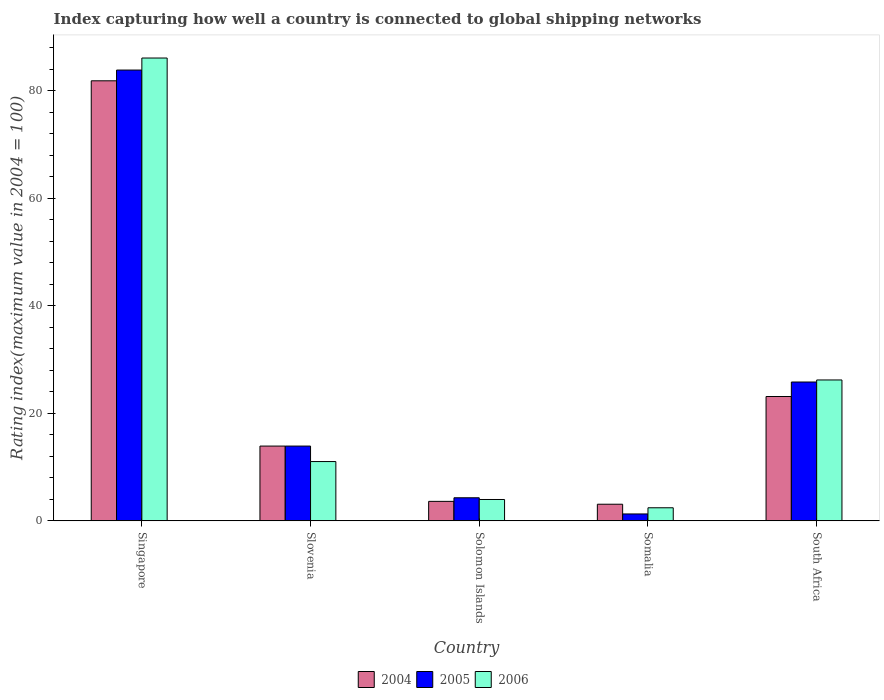How many different coloured bars are there?
Keep it short and to the point. 3. How many groups of bars are there?
Give a very brief answer. 5. Are the number of bars on each tick of the X-axis equal?
Your answer should be very brief. Yes. How many bars are there on the 5th tick from the left?
Make the answer very short. 3. What is the label of the 4th group of bars from the left?
Give a very brief answer. Somalia. What is the rating index in 2005 in South Africa?
Your response must be concise. 25.83. Across all countries, what is the maximum rating index in 2004?
Your answer should be compact. 81.87. Across all countries, what is the minimum rating index in 2004?
Your response must be concise. 3.09. In which country was the rating index in 2004 maximum?
Provide a short and direct response. Singapore. In which country was the rating index in 2004 minimum?
Ensure brevity in your answer.  Somalia. What is the total rating index in 2006 in the graph?
Your response must be concise. 129.75. What is the difference between the rating index in 2005 in Singapore and that in Solomon Islands?
Make the answer very short. 79.58. What is the difference between the rating index in 2006 in Slovenia and the rating index in 2005 in Singapore?
Provide a short and direct response. -72.84. What is the average rating index in 2005 per country?
Provide a succinct answer. 25.84. What is the difference between the rating index of/in 2006 and rating index of/in 2005 in Somalia?
Give a very brief answer. 1.15. What is the ratio of the rating index in 2005 in Slovenia to that in Solomon Islands?
Offer a very short reply. 3.24. Is the rating index in 2006 in Solomon Islands less than that in Somalia?
Your answer should be compact. No. Is the difference between the rating index in 2006 in Singapore and Slovenia greater than the difference between the rating index in 2005 in Singapore and Slovenia?
Your response must be concise. Yes. What is the difference between the highest and the second highest rating index in 2005?
Ensure brevity in your answer.  -58.04. What is the difference between the highest and the lowest rating index in 2005?
Provide a short and direct response. 82.59. Is the sum of the rating index in 2004 in Singapore and Solomon Islands greater than the maximum rating index in 2005 across all countries?
Offer a very short reply. Yes. Is it the case that in every country, the sum of the rating index in 2006 and rating index in 2005 is greater than the rating index in 2004?
Provide a short and direct response. Yes. Are all the bars in the graph horizontal?
Provide a succinct answer. No. Are the values on the major ticks of Y-axis written in scientific E-notation?
Give a very brief answer. No. Does the graph contain any zero values?
Your response must be concise. No. How many legend labels are there?
Your response must be concise. 3. How are the legend labels stacked?
Offer a terse response. Horizontal. What is the title of the graph?
Ensure brevity in your answer.  Index capturing how well a country is connected to global shipping networks. What is the label or title of the Y-axis?
Offer a very short reply. Rating index(maximum value in 2004 = 100). What is the Rating index(maximum value in 2004 = 100) in 2004 in Singapore?
Keep it short and to the point. 81.87. What is the Rating index(maximum value in 2004 = 100) in 2005 in Singapore?
Ensure brevity in your answer.  83.87. What is the Rating index(maximum value in 2004 = 100) of 2006 in Singapore?
Provide a succinct answer. 86.11. What is the Rating index(maximum value in 2004 = 100) of 2004 in Slovenia?
Provide a short and direct response. 13.91. What is the Rating index(maximum value in 2004 = 100) of 2005 in Slovenia?
Ensure brevity in your answer.  13.91. What is the Rating index(maximum value in 2004 = 100) of 2006 in Slovenia?
Make the answer very short. 11.03. What is the Rating index(maximum value in 2004 = 100) of 2004 in Solomon Islands?
Your answer should be compact. 3.62. What is the Rating index(maximum value in 2004 = 100) in 2005 in Solomon Islands?
Make the answer very short. 4.29. What is the Rating index(maximum value in 2004 = 100) of 2006 in Solomon Islands?
Make the answer very short. 3.97. What is the Rating index(maximum value in 2004 = 100) in 2004 in Somalia?
Provide a short and direct response. 3.09. What is the Rating index(maximum value in 2004 = 100) of 2005 in Somalia?
Give a very brief answer. 1.28. What is the Rating index(maximum value in 2004 = 100) in 2006 in Somalia?
Keep it short and to the point. 2.43. What is the Rating index(maximum value in 2004 = 100) of 2004 in South Africa?
Offer a terse response. 23.13. What is the Rating index(maximum value in 2004 = 100) of 2005 in South Africa?
Keep it short and to the point. 25.83. What is the Rating index(maximum value in 2004 = 100) in 2006 in South Africa?
Give a very brief answer. 26.21. Across all countries, what is the maximum Rating index(maximum value in 2004 = 100) in 2004?
Provide a succinct answer. 81.87. Across all countries, what is the maximum Rating index(maximum value in 2004 = 100) of 2005?
Your response must be concise. 83.87. Across all countries, what is the maximum Rating index(maximum value in 2004 = 100) in 2006?
Provide a succinct answer. 86.11. Across all countries, what is the minimum Rating index(maximum value in 2004 = 100) in 2004?
Your answer should be very brief. 3.09. Across all countries, what is the minimum Rating index(maximum value in 2004 = 100) in 2005?
Your response must be concise. 1.28. Across all countries, what is the minimum Rating index(maximum value in 2004 = 100) of 2006?
Keep it short and to the point. 2.43. What is the total Rating index(maximum value in 2004 = 100) in 2004 in the graph?
Your answer should be very brief. 125.62. What is the total Rating index(maximum value in 2004 = 100) in 2005 in the graph?
Offer a very short reply. 129.18. What is the total Rating index(maximum value in 2004 = 100) of 2006 in the graph?
Give a very brief answer. 129.75. What is the difference between the Rating index(maximum value in 2004 = 100) in 2004 in Singapore and that in Slovenia?
Make the answer very short. 67.96. What is the difference between the Rating index(maximum value in 2004 = 100) of 2005 in Singapore and that in Slovenia?
Offer a very short reply. 69.96. What is the difference between the Rating index(maximum value in 2004 = 100) of 2006 in Singapore and that in Slovenia?
Offer a terse response. 75.08. What is the difference between the Rating index(maximum value in 2004 = 100) of 2004 in Singapore and that in Solomon Islands?
Your answer should be compact. 78.25. What is the difference between the Rating index(maximum value in 2004 = 100) of 2005 in Singapore and that in Solomon Islands?
Provide a short and direct response. 79.58. What is the difference between the Rating index(maximum value in 2004 = 100) of 2006 in Singapore and that in Solomon Islands?
Make the answer very short. 82.14. What is the difference between the Rating index(maximum value in 2004 = 100) of 2004 in Singapore and that in Somalia?
Offer a very short reply. 78.78. What is the difference between the Rating index(maximum value in 2004 = 100) in 2005 in Singapore and that in Somalia?
Provide a short and direct response. 82.59. What is the difference between the Rating index(maximum value in 2004 = 100) in 2006 in Singapore and that in Somalia?
Offer a very short reply. 83.68. What is the difference between the Rating index(maximum value in 2004 = 100) of 2004 in Singapore and that in South Africa?
Give a very brief answer. 58.74. What is the difference between the Rating index(maximum value in 2004 = 100) of 2005 in Singapore and that in South Africa?
Give a very brief answer. 58.04. What is the difference between the Rating index(maximum value in 2004 = 100) in 2006 in Singapore and that in South Africa?
Provide a short and direct response. 59.9. What is the difference between the Rating index(maximum value in 2004 = 100) in 2004 in Slovenia and that in Solomon Islands?
Your answer should be compact. 10.29. What is the difference between the Rating index(maximum value in 2004 = 100) of 2005 in Slovenia and that in Solomon Islands?
Your answer should be compact. 9.62. What is the difference between the Rating index(maximum value in 2004 = 100) of 2006 in Slovenia and that in Solomon Islands?
Your response must be concise. 7.06. What is the difference between the Rating index(maximum value in 2004 = 100) in 2004 in Slovenia and that in Somalia?
Your answer should be very brief. 10.82. What is the difference between the Rating index(maximum value in 2004 = 100) in 2005 in Slovenia and that in Somalia?
Offer a very short reply. 12.63. What is the difference between the Rating index(maximum value in 2004 = 100) of 2006 in Slovenia and that in Somalia?
Your response must be concise. 8.6. What is the difference between the Rating index(maximum value in 2004 = 100) of 2004 in Slovenia and that in South Africa?
Provide a succinct answer. -9.22. What is the difference between the Rating index(maximum value in 2004 = 100) of 2005 in Slovenia and that in South Africa?
Keep it short and to the point. -11.92. What is the difference between the Rating index(maximum value in 2004 = 100) in 2006 in Slovenia and that in South Africa?
Your answer should be compact. -15.18. What is the difference between the Rating index(maximum value in 2004 = 100) in 2004 in Solomon Islands and that in Somalia?
Offer a terse response. 0.53. What is the difference between the Rating index(maximum value in 2004 = 100) in 2005 in Solomon Islands and that in Somalia?
Offer a very short reply. 3.01. What is the difference between the Rating index(maximum value in 2004 = 100) of 2006 in Solomon Islands and that in Somalia?
Your answer should be very brief. 1.54. What is the difference between the Rating index(maximum value in 2004 = 100) of 2004 in Solomon Islands and that in South Africa?
Your answer should be very brief. -19.51. What is the difference between the Rating index(maximum value in 2004 = 100) of 2005 in Solomon Islands and that in South Africa?
Provide a short and direct response. -21.54. What is the difference between the Rating index(maximum value in 2004 = 100) of 2006 in Solomon Islands and that in South Africa?
Ensure brevity in your answer.  -22.24. What is the difference between the Rating index(maximum value in 2004 = 100) of 2004 in Somalia and that in South Africa?
Offer a terse response. -20.04. What is the difference between the Rating index(maximum value in 2004 = 100) of 2005 in Somalia and that in South Africa?
Offer a very short reply. -24.55. What is the difference between the Rating index(maximum value in 2004 = 100) in 2006 in Somalia and that in South Africa?
Keep it short and to the point. -23.78. What is the difference between the Rating index(maximum value in 2004 = 100) in 2004 in Singapore and the Rating index(maximum value in 2004 = 100) in 2005 in Slovenia?
Provide a succinct answer. 67.96. What is the difference between the Rating index(maximum value in 2004 = 100) of 2004 in Singapore and the Rating index(maximum value in 2004 = 100) of 2006 in Slovenia?
Make the answer very short. 70.84. What is the difference between the Rating index(maximum value in 2004 = 100) in 2005 in Singapore and the Rating index(maximum value in 2004 = 100) in 2006 in Slovenia?
Provide a succinct answer. 72.84. What is the difference between the Rating index(maximum value in 2004 = 100) of 2004 in Singapore and the Rating index(maximum value in 2004 = 100) of 2005 in Solomon Islands?
Your response must be concise. 77.58. What is the difference between the Rating index(maximum value in 2004 = 100) of 2004 in Singapore and the Rating index(maximum value in 2004 = 100) of 2006 in Solomon Islands?
Offer a very short reply. 77.9. What is the difference between the Rating index(maximum value in 2004 = 100) in 2005 in Singapore and the Rating index(maximum value in 2004 = 100) in 2006 in Solomon Islands?
Provide a short and direct response. 79.9. What is the difference between the Rating index(maximum value in 2004 = 100) of 2004 in Singapore and the Rating index(maximum value in 2004 = 100) of 2005 in Somalia?
Your response must be concise. 80.59. What is the difference between the Rating index(maximum value in 2004 = 100) in 2004 in Singapore and the Rating index(maximum value in 2004 = 100) in 2006 in Somalia?
Give a very brief answer. 79.44. What is the difference between the Rating index(maximum value in 2004 = 100) of 2005 in Singapore and the Rating index(maximum value in 2004 = 100) of 2006 in Somalia?
Offer a very short reply. 81.44. What is the difference between the Rating index(maximum value in 2004 = 100) in 2004 in Singapore and the Rating index(maximum value in 2004 = 100) in 2005 in South Africa?
Your answer should be very brief. 56.04. What is the difference between the Rating index(maximum value in 2004 = 100) of 2004 in Singapore and the Rating index(maximum value in 2004 = 100) of 2006 in South Africa?
Your answer should be very brief. 55.66. What is the difference between the Rating index(maximum value in 2004 = 100) of 2005 in Singapore and the Rating index(maximum value in 2004 = 100) of 2006 in South Africa?
Provide a short and direct response. 57.66. What is the difference between the Rating index(maximum value in 2004 = 100) in 2004 in Slovenia and the Rating index(maximum value in 2004 = 100) in 2005 in Solomon Islands?
Your answer should be very brief. 9.62. What is the difference between the Rating index(maximum value in 2004 = 100) in 2004 in Slovenia and the Rating index(maximum value in 2004 = 100) in 2006 in Solomon Islands?
Make the answer very short. 9.94. What is the difference between the Rating index(maximum value in 2004 = 100) in 2005 in Slovenia and the Rating index(maximum value in 2004 = 100) in 2006 in Solomon Islands?
Your response must be concise. 9.94. What is the difference between the Rating index(maximum value in 2004 = 100) of 2004 in Slovenia and the Rating index(maximum value in 2004 = 100) of 2005 in Somalia?
Provide a succinct answer. 12.63. What is the difference between the Rating index(maximum value in 2004 = 100) in 2004 in Slovenia and the Rating index(maximum value in 2004 = 100) in 2006 in Somalia?
Your answer should be very brief. 11.48. What is the difference between the Rating index(maximum value in 2004 = 100) in 2005 in Slovenia and the Rating index(maximum value in 2004 = 100) in 2006 in Somalia?
Give a very brief answer. 11.48. What is the difference between the Rating index(maximum value in 2004 = 100) of 2004 in Slovenia and the Rating index(maximum value in 2004 = 100) of 2005 in South Africa?
Provide a succinct answer. -11.92. What is the difference between the Rating index(maximum value in 2004 = 100) in 2004 in Solomon Islands and the Rating index(maximum value in 2004 = 100) in 2005 in Somalia?
Provide a short and direct response. 2.34. What is the difference between the Rating index(maximum value in 2004 = 100) in 2004 in Solomon Islands and the Rating index(maximum value in 2004 = 100) in 2006 in Somalia?
Your answer should be compact. 1.19. What is the difference between the Rating index(maximum value in 2004 = 100) of 2005 in Solomon Islands and the Rating index(maximum value in 2004 = 100) of 2006 in Somalia?
Ensure brevity in your answer.  1.86. What is the difference between the Rating index(maximum value in 2004 = 100) of 2004 in Solomon Islands and the Rating index(maximum value in 2004 = 100) of 2005 in South Africa?
Ensure brevity in your answer.  -22.21. What is the difference between the Rating index(maximum value in 2004 = 100) in 2004 in Solomon Islands and the Rating index(maximum value in 2004 = 100) in 2006 in South Africa?
Offer a terse response. -22.59. What is the difference between the Rating index(maximum value in 2004 = 100) of 2005 in Solomon Islands and the Rating index(maximum value in 2004 = 100) of 2006 in South Africa?
Give a very brief answer. -21.92. What is the difference between the Rating index(maximum value in 2004 = 100) in 2004 in Somalia and the Rating index(maximum value in 2004 = 100) in 2005 in South Africa?
Provide a short and direct response. -22.74. What is the difference between the Rating index(maximum value in 2004 = 100) in 2004 in Somalia and the Rating index(maximum value in 2004 = 100) in 2006 in South Africa?
Make the answer very short. -23.12. What is the difference between the Rating index(maximum value in 2004 = 100) of 2005 in Somalia and the Rating index(maximum value in 2004 = 100) of 2006 in South Africa?
Your answer should be very brief. -24.93. What is the average Rating index(maximum value in 2004 = 100) in 2004 per country?
Offer a terse response. 25.12. What is the average Rating index(maximum value in 2004 = 100) in 2005 per country?
Make the answer very short. 25.84. What is the average Rating index(maximum value in 2004 = 100) of 2006 per country?
Give a very brief answer. 25.95. What is the difference between the Rating index(maximum value in 2004 = 100) of 2004 and Rating index(maximum value in 2004 = 100) of 2005 in Singapore?
Ensure brevity in your answer.  -2. What is the difference between the Rating index(maximum value in 2004 = 100) of 2004 and Rating index(maximum value in 2004 = 100) of 2006 in Singapore?
Keep it short and to the point. -4.24. What is the difference between the Rating index(maximum value in 2004 = 100) of 2005 and Rating index(maximum value in 2004 = 100) of 2006 in Singapore?
Give a very brief answer. -2.24. What is the difference between the Rating index(maximum value in 2004 = 100) in 2004 and Rating index(maximum value in 2004 = 100) in 2005 in Slovenia?
Provide a short and direct response. 0. What is the difference between the Rating index(maximum value in 2004 = 100) of 2004 and Rating index(maximum value in 2004 = 100) of 2006 in Slovenia?
Keep it short and to the point. 2.88. What is the difference between the Rating index(maximum value in 2004 = 100) of 2005 and Rating index(maximum value in 2004 = 100) of 2006 in Slovenia?
Ensure brevity in your answer.  2.88. What is the difference between the Rating index(maximum value in 2004 = 100) of 2004 and Rating index(maximum value in 2004 = 100) of 2005 in Solomon Islands?
Keep it short and to the point. -0.67. What is the difference between the Rating index(maximum value in 2004 = 100) in 2004 and Rating index(maximum value in 2004 = 100) in 2006 in Solomon Islands?
Make the answer very short. -0.35. What is the difference between the Rating index(maximum value in 2004 = 100) in 2005 and Rating index(maximum value in 2004 = 100) in 2006 in Solomon Islands?
Provide a succinct answer. 0.32. What is the difference between the Rating index(maximum value in 2004 = 100) of 2004 and Rating index(maximum value in 2004 = 100) of 2005 in Somalia?
Keep it short and to the point. 1.81. What is the difference between the Rating index(maximum value in 2004 = 100) in 2004 and Rating index(maximum value in 2004 = 100) in 2006 in Somalia?
Your answer should be very brief. 0.66. What is the difference between the Rating index(maximum value in 2004 = 100) of 2005 and Rating index(maximum value in 2004 = 100) of 2006 in Somalia?
Your answer should be very brief. -1.15. What is the difference between the Rating index(maximum value in 2004 = 100) of 2004 and Rating index(maximum value in 2004 = 100) of 2006 in South Africa?
Give a very brief answer. -3.08. What is the difference between the Rating index(maximum value in 2004 = 100) of 2005 and Rating index(maximum value in 2004 = 100) of 2006 in South Africa?
Your answer should be compact. -0.38. What is the ratio of the Rating index(maximum value in 2004 = 100) of 2004 in Singapore to that in Slovenia?
Provide a short and direct response. 5.89. What is the ratio of the Rating index(maximum value in 2004 = 100) of 2005 in Singapore to that in Slovenia?
Provide a succinct answer. 6.03. What is the ratio of the Rating index(maximum value in 2004 = 100) in 2006 in Singapore to that in Slovenia?
Offer a terse response. 7.81. What is the ratio of the Rating index(maximum value in 2004 = 100) in 2004 in Singapore to that in Solomon Islands?
Your answer should be very brief. 22.62. What is the ratio of the Rating index(maximum value in 2004 = 100) of 2005 in Singapore to that in Solomon Islands?
Make the answer very short. 19.55. What is the ratio of the Rating index(maximum value in 2004 = 100) in 2006 in Singapore to that in Solomon Islands?
Ensure brevity in your answer.  21.69. What is the ratio of the Rating index(maximum value in 2004 = 100) in 2004 in Singapore to that in Somalia?
Make the answer very short. 26.5. What is the ratio of the Rating index(maximum value in 2004 = 100) of 2005 in Singapore to that in Somalia?
Provide a short and direct response. 65.52. What is the ratio of the Rating index(maximum value in 2004 = 100) of 2006 in Singapore to that in Somalia?
Your answer should be very brief. 35.44. What is the ratio of the Rating index(maximum value in 2004 = 100) in 2004 in Singapore to that in South Africa?
Offer a very short reply. 3.54. What is the ratio of the Rating index(maximum value in 2004 = 100) in 2005 in Singapore to that in South Africa?
Provide a short and direct response. 3.25. What is the ratio of the Rating index(maximum value in 2004 = 100) of 2006 in Singapore to that in South Africa?
Your response must be concise. 3.29. What is the ratio of the Rating index(maximum value in 2004 = 100) of 2004 in Slovenia to that in Solomon Islands?
Offer a terse response. 3.84. What is the ratio of the Rating index(maximum value in 2004 = 100) of 2005 in Slovenia to that in Solomon Islands?
Your response must be concise. 3.24. What is the ratio of the Rating index(maximum value in 2004 = 100) of 2006 in Slovenia to that in Solomon Islands?
Keep it short and to the point. 2.78. What is the ratio of the Rating index(maximum value in 2004 = 100) of 2004 in Slovenia to that in Somalia?
Offer a very short reply. 4.5. What is the ratio of the Rating index(maximum value in 2004 = 100) of 2005 in Slovenia to that in Somalia?
Provide a short and direct response. 10.87. What is the ratio of the Rating index(maximum value in 2004 = 100) in 2006 in Slovenia to that in Somalia?
Ensure brevity in your answer.  4.54. What is the ratio of the Rating index(maximum value in 2004 = 100) in 2004 in Slovenia to that in South Africa?
Give a very brief answer. 0.6. What is the ratio of the Rating index(maximum value in 2004 = 100) in 2005 in Slovenia to that in South Africa?
Ensure brevity in your answer.  0.54. What is the ratio of the Rating index(maximum value in 2004 = 100) of 2006 in Slovenia to that in South Africa?
Provide a short and direct response. 0.42. What is the ratio of the Rating index(maximum value in 2004 = 100) in 2004 in Solomon Islands to that in Somalia?
Offer a very short reply. 1.17. What is the ratio of the Rating index(maximum value in 2004 = 100) of 2005 in Solomon Islands to that in Somalia?
Offer a very short reply. 3.35. What is the ratio of the Rating index(maximum value in 2004 = 100) of 2006 in Solomon Islands to that in Somalia?
Ensure brevity in your answer.  1.63. What is the ratio of the Rating index(maximum value in 2004 = 100) of 2004 in Solomon Islands to that in South Africa?
Your answer should be compact. 0.16. What is the ratio of the Rating index(maximum value in 2004 = 100) in 2005 in Solomon Islands to that in South Africa?
Your response must be concise. 0.17. What is the ratio of the Rating index(maximum value in 2004 = 100) of 2006 in Solomon Islands to that in South Africa?
Give a very brief answer. 0.15. What is the ratio of the Rating index(maximum value in 2004 = 100) in 2004 in Somalia to that in South Africa?
Offer a terse response. 0.13. What is the ratio of the Rating index(maximum value in 2004 = 100) in 2005 in Somalia to that in South Africa?
Ensure brevity in your answer.  0.05. What is the ratio of the Rating index(maximum value in 2004 = 100) in 2006 in Somalia to that in South Africa?
Your response must be concise. 0.09. What is the difference between the highest and the second highest Rating index(maximum value in 2004 = 100) of 2004?
Provide a succinct answer. 58.74. What is the difference between the highest and the second highest Rating index(maximum value in 2004 = 100) of 2005?
Ensure brevity in your answer.  58.04. What is the difference between the highest and the second highest Rating index(maximum value in 2004 = 100) in 2006?
Your answer should be very brief. 59.9. What is the difference between the highest and the lowest Rating index(maximum value in 2004 = 100) in 2004?
Your answer should be very brief. 78.78. What is the difference between the highest and the lowest Rating index(maximum value in 2004 = 100) in 2005?
Your answer should be compact. 82.59. What is the difference between the highest and the lowest Rating index(maximum value in 2004 = 100) in 2006?
Your answer should be compact. 83.68. 